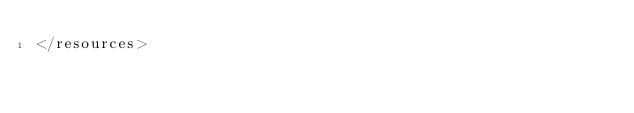<code> <loc_0><loc_0><loc_500><loc_500><_XML_></resources>
</code> 